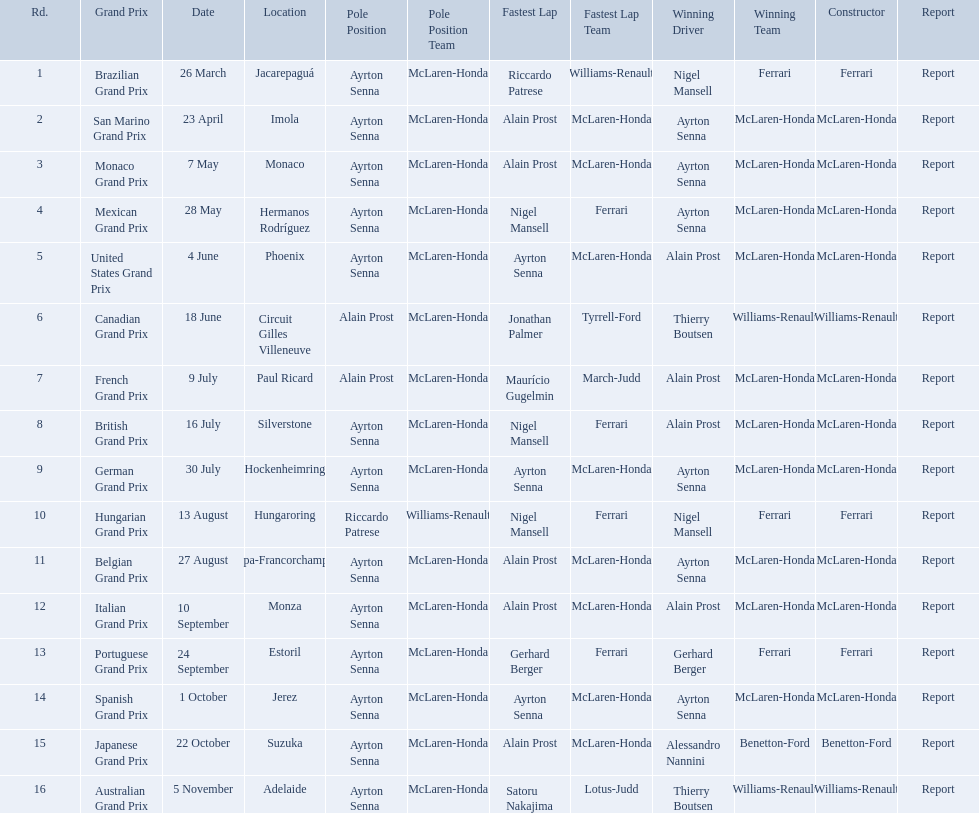Who are the constructors in the 1989 formula one season? Ferrari, McLaren-Honda, McLaren-Honda, McLaren-Honda, McLaren-Honda, Williams-Renault, McLaren-Honda, McLaren-Honda, McLaren-Honda, Ferrari, McLaren-Honda, McLaren-Honda, Ferrari, McLaren-Honda, Benetton-Ford, Williams-Renault. On what date was bennington ford the constructor? 22 October. What was the race on october 22? Japanese Grand Prix. Who won the spanish grand prix? McLaren-Honda. Who won the italian grand prix? McLaren-Honda. What grand prix did benneton-ford win? Japanese Grand Prix. 